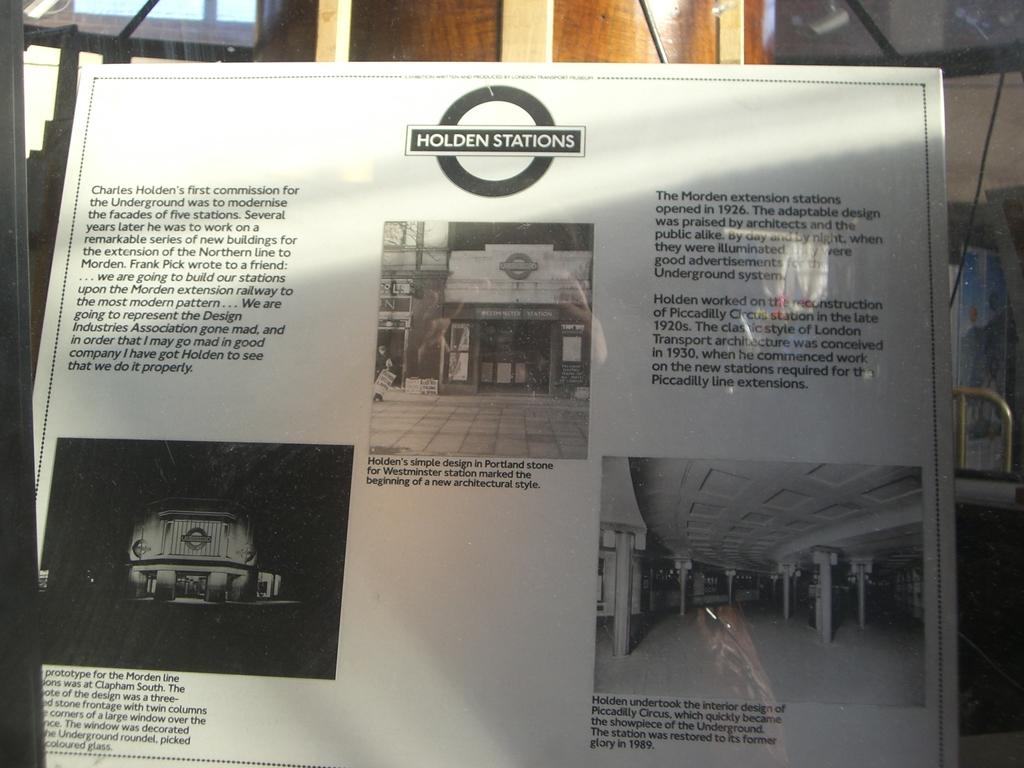When were the holden stations invented?
Provide a short and direct response. 1926. What was holden's first name?
Give a very brief answer. Charles. 